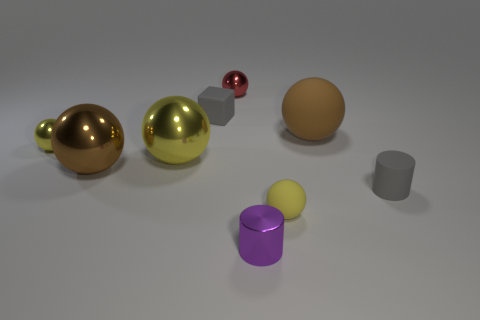Subtract all yellow spheres. How many were subtracted if there are1yellow spheres left? 2 Subtract all big yellow spheres. How many spheres are left? 5 Subtract all purple cylinders. How many yellow balls are left? 3 Add 1 red shiny balls. How many objects exist? 10 Subtract all brown balls. How many balls are left? 4 Subtract all spheres. How many objects are left? 3 Subtract 1 cylinders. How many cylinders are left? 1 Subtract all brown rubber spheres. Subtract all big yellow things. How many objects are left? 7 Add 5 large things. How many large things are left? 8 Add 7 brown shiny things. How many brown shiny things exist? 8 